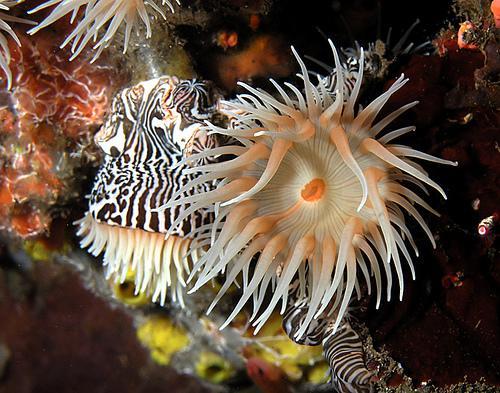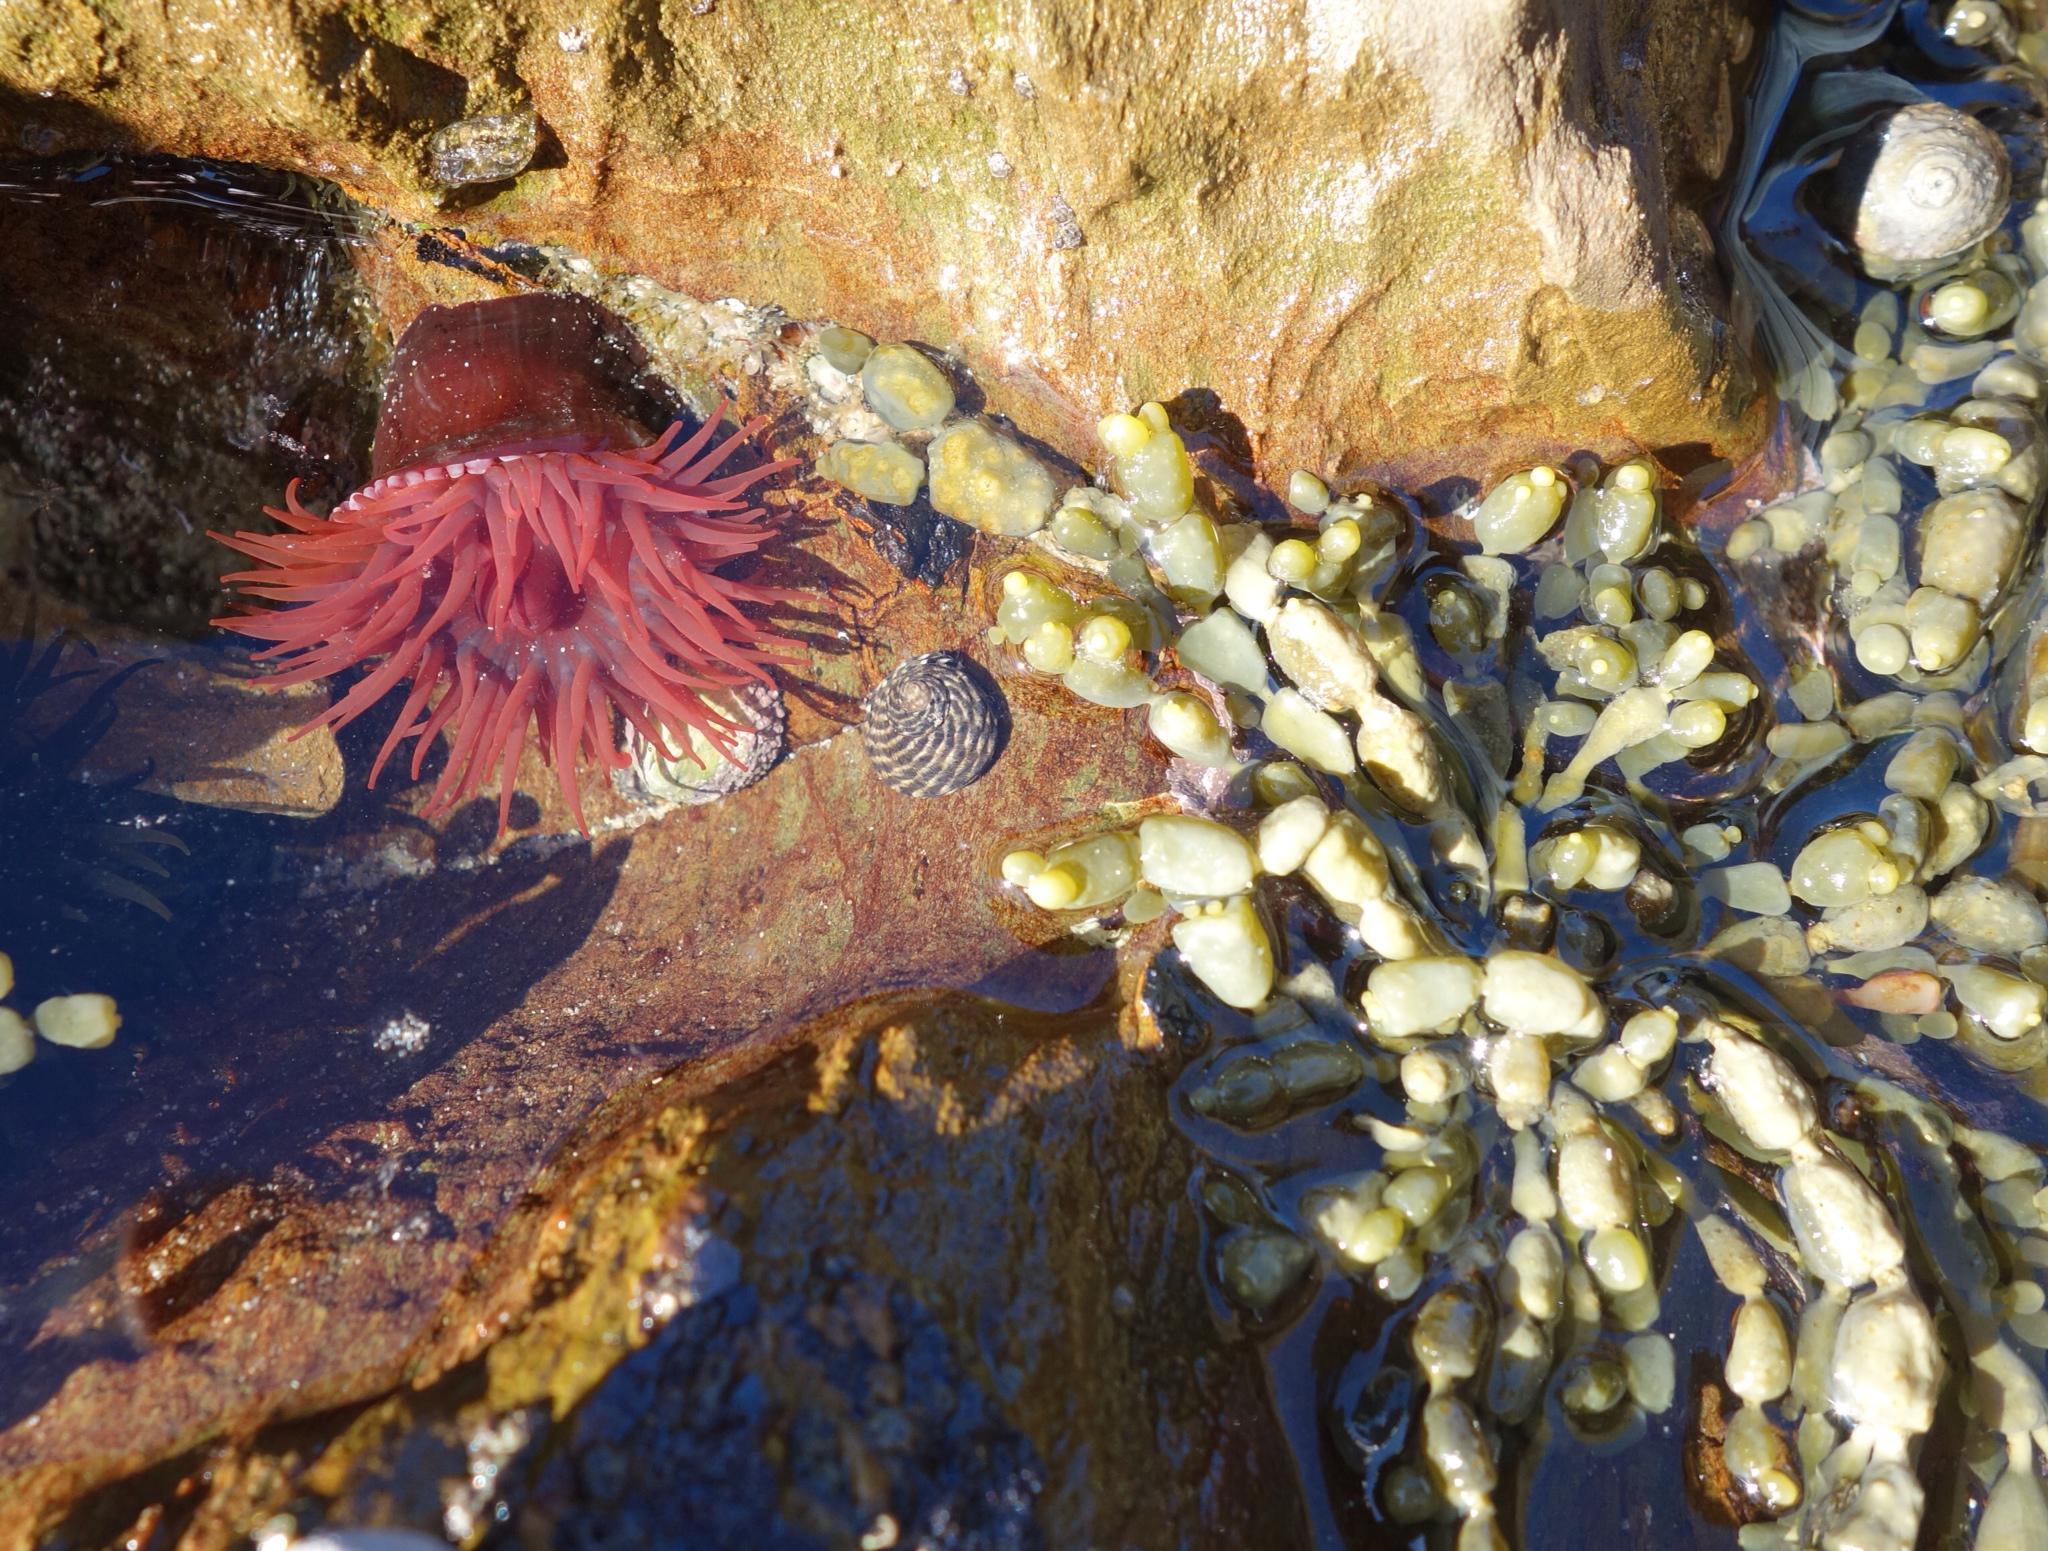The first image is the image on the left, the second image is the image on the right. Assess this claim about the two images: "An image includes an anemone with pink tendrils trailing down from a darker stout red stalk.". Correct or not? Answer yes or no. Yes. 